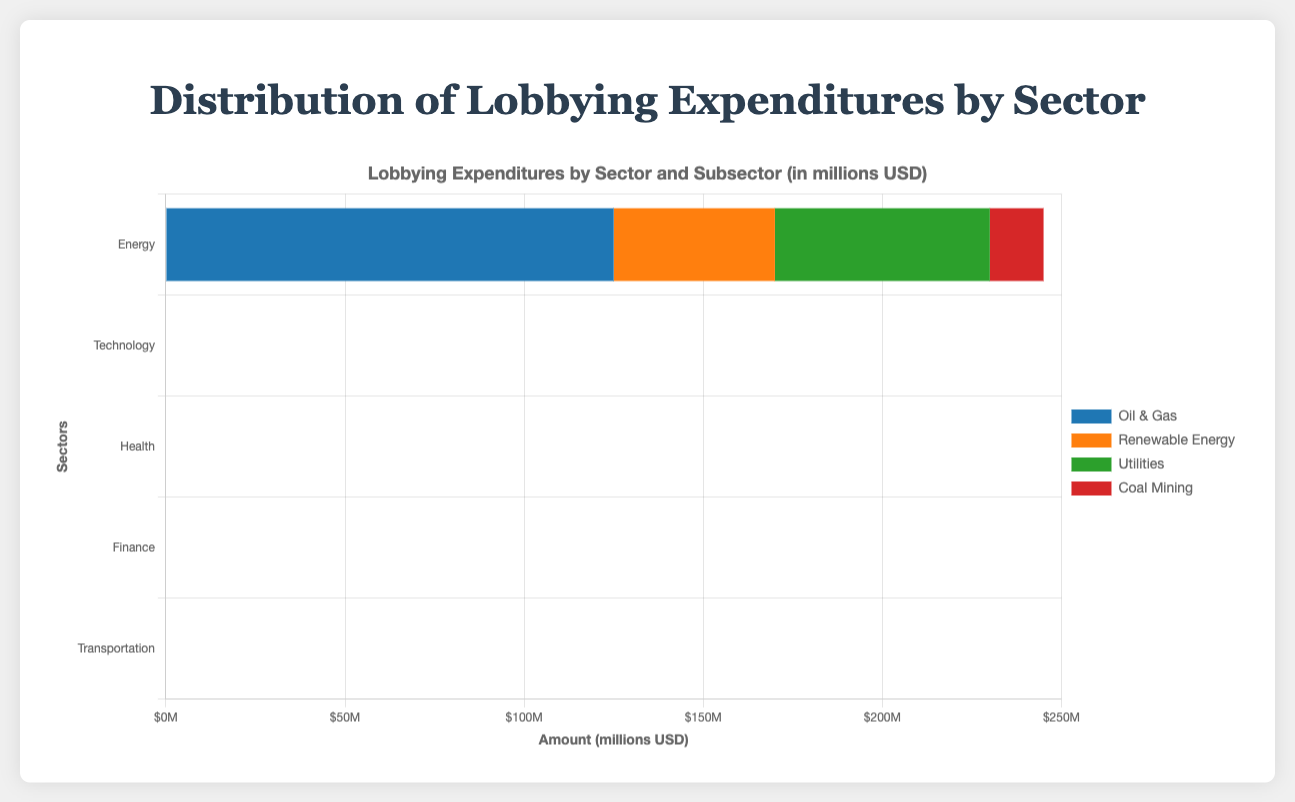Which sector has the highest total lobbying expenditure? By adding the expenditures of each sector's subsectors, the total amounts are: Energy (245M), Technology (200M), Health (180M), Finance (220M), and Transportation (95M). The Energy sector has the highest total.
Answer: Energy What is the total amount spent by the Energy sector? Adding the expenditures of all Energy subsectors: Oil & Gas (125M), Renewable Energy (45M), Utilities (60M), Coal Mining (15M) results in a total of 245M.
Answer: 245M How much more lobbying expenditure is there in the Energy sector compared to the Technology sector? The total for Energy is 245M. The total for Technology is 200M. The difference is 45M.
Answer: 45M Which subsector in the Health sector has the lowest lobbying expenditure? Comparing the subsectors in Health: Pharmaceuticals (100M), Health Services (50M), Insurance (30M), the Insurance subsector has the lowest expenditure.
Answer: Insurance Which sector spends the most on Oil & Gas compared to any other sector's highest-spending subsector? The Oil & Gas subsector in Energy spends 125M, which is more than any other subsector’s highest expenditure: Pharmaceuticals in Health (100M), Software in Technology (80M), Banking in Finance (90M), and Airlines in Transportation (40M).
Answer: Energy's Oil & Gas What is the exact lobbying expenditure for Renewable Energy in the Energy sector? The data shows the amount spent on Renewable Energy within the Energy sector is directly listed as 45M.
Answer: 45M Which subsector has the largest lobbying expenditure across all sectors? Comparing the highest expenditures in all subsectors: Oil & Gas (125M), Software (80M), Pharmaceuticals (100M), Banking (90M), and Airlines (40M), Oil & Gas has the largest expenditure.
Answer: Oil & Gas How does the expenditure of Coal Mining in the Energy sector compare to the expenditure of Railways in the Transportation sector? Coal Mining in Energy spends 15M, whereas Railways in Transportation spends 25M. Therefore, Coal Mining spends 10M less than Railways.
Answer: Coal Mining spends 10M less What is the combined lobbying expenditure of the Pharmaceutical and Health Services subsectors in the Health sector? Pharmaceuticals spends 100M and Health Services spends 50M. Their combined expenditure is 150M.
Answer: 150M How much more is spent on Banking compared to Insurance in the Finance sector? Banking spends 90M, and Insurance spends 60M, hence, Banking spends 30M more than Insurance in the Finance sector.
Answer: 30M 